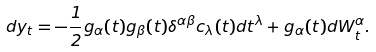<formula> <loc_0><loc_0><loc_500><loc_500>d y _ { t } = - \frac { 1 } { 2 } g _ { \alpha } ( t ) g _ { \beta } ( t ) \delta ^ { \alpha \beta } c _ { \lambda } ( t ) d t ^ { \lambda } + g _ { \alpha } ( t ) d W _ { t } ^ { \alpha } .</formula> 